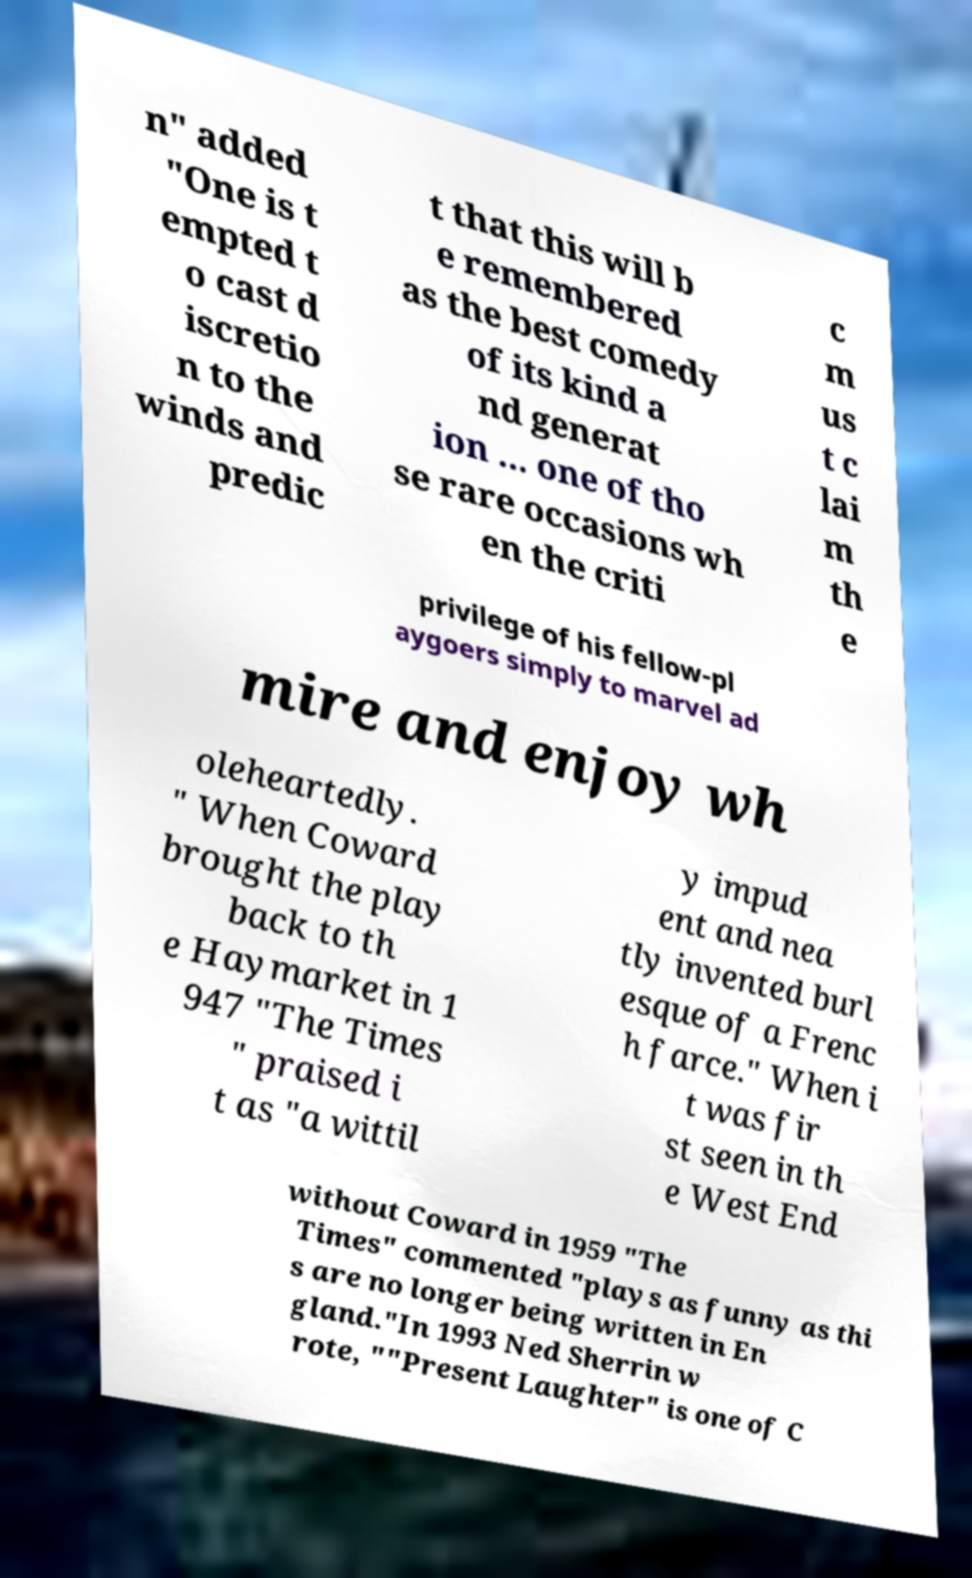For documentation purposes, I need the text within this image transcribed. Could you provide that? n" added "One is t empted t o cast d iscretio n to the winds and predic t that this will b e remembered as the best comedy of its kind a nd generat ion ... one of tho se rare occasions wh en the criti c m us t c lai m th e privilege of his fellow-pl aygoers simply to marvel ad mire and enjoy wh oleheartedly. " When Coward brought the play back to th e Haymarket in 1 947 "The Times " praised i t as "a wittil y impud ent and nea tly invented burl esque of a Frenc h farce." When i t was fir st seen in th e West End without Coward in 1959 "The Times" commented "plays as funny as thi s are no longer being written in En gland."In 1993 Ned Sherrin w rote, ""Present Laughter" is one of C 